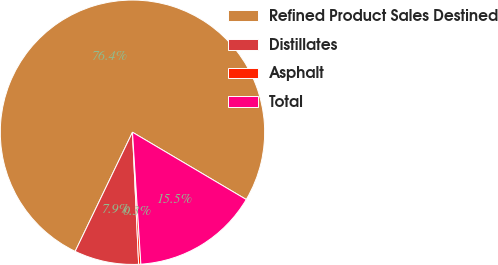<chart> <loc_0><loc_0><loc_500><loc_500><pie_chart><fcel>Refined Product Sales Destined<fcel>Distillates<fcel>Asphalt<fcel>Total<nl><fcel>76.37%<fcel>7.88%<fcel>0.27%<fcel>15.49%<nl></chart> 